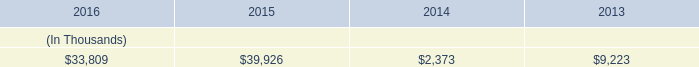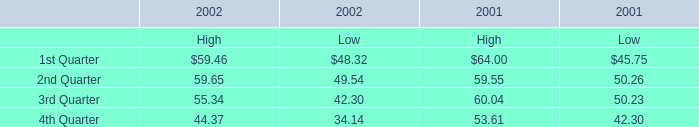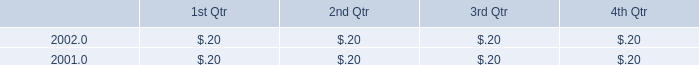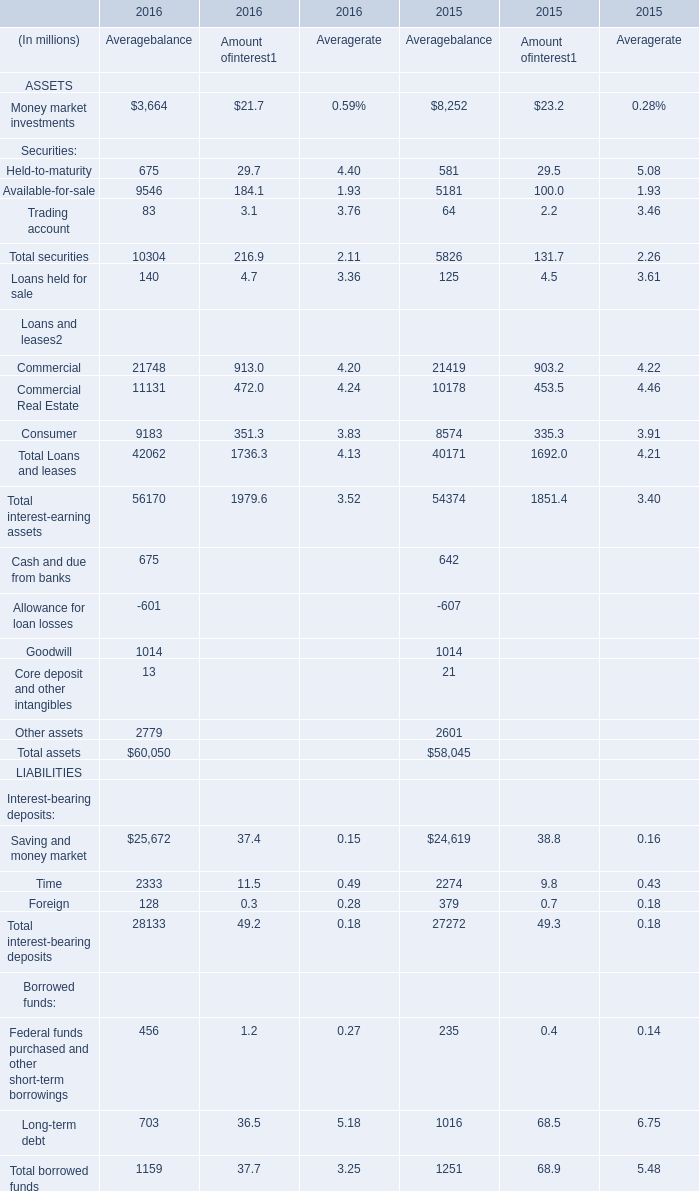If Trading account for Amount of interest develops with the same increasing rate in 2016, what will it reach in 2017? (in million) 
Computations: ((((3.1 - 2.2) / 2.2) + 1) * 3.1)
Answer: 4.36818. 